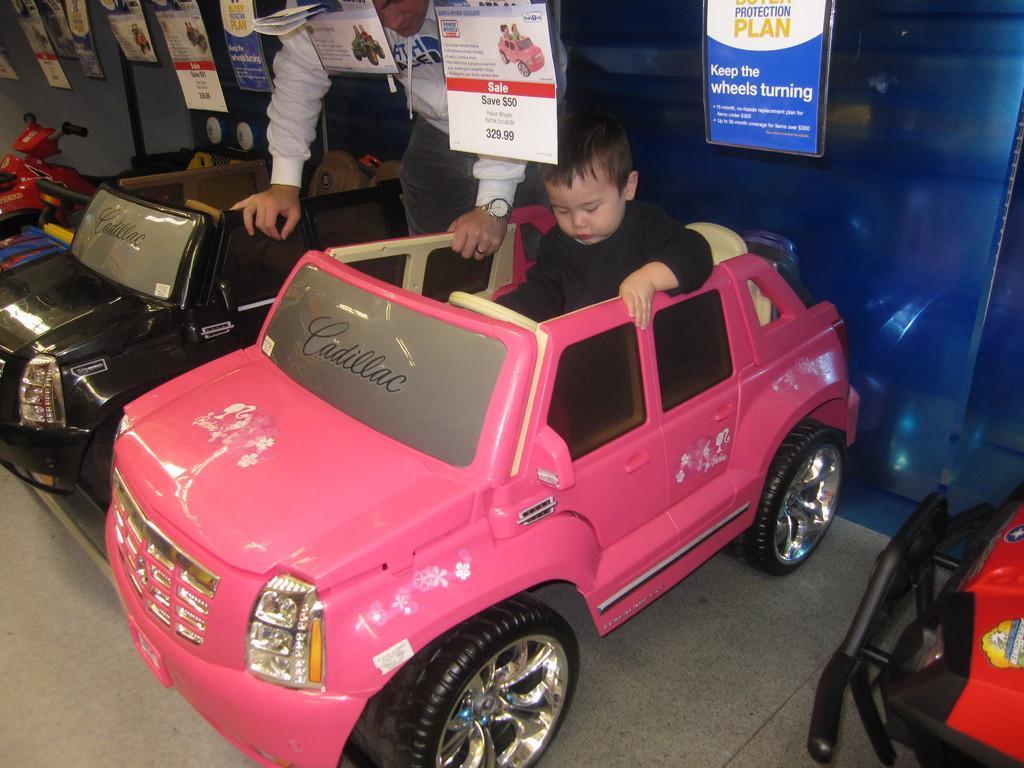Please provide a concise description of this image. In the image we can see some toy vehicles, in the vehicle a boy is sitting. Behind the vehicles a person is standing and there are some banners. Behind them there is wall. 